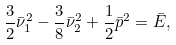<formula> <loc_0><loc_0><loc_500><loc_500>\frac { 3 } { 2 } \bar { \nu } _ { 1 } ^ { 2 } - \frac { 3 } { 8 } \bar { \nu } _ { 2 } ^ { 2 } + \frac { 1 } { 2 } \bar { p } ^ { 2 } = \bar { E } ,</formula> 